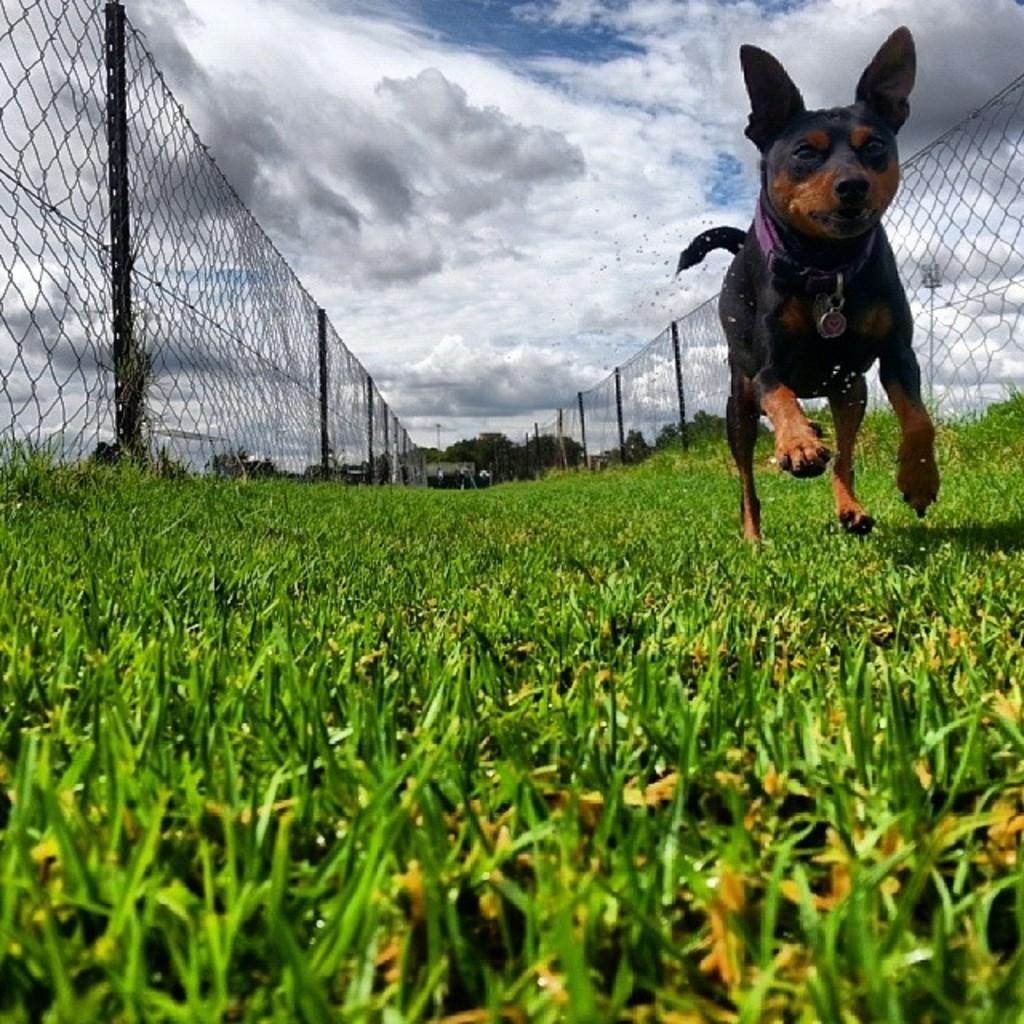What can be seen in the sky in the image? There are clouds in the sky in the image. What type of structure is present in the image? There is fencing in the image. What type of vegetation is visible in the image? There is grass in the image. What is the dog in the image doing? There is a dog running in the image. Which direction is the army marching in the image? There is no army present in the image, so it is not possible to determine the direction in which they might be marching. 